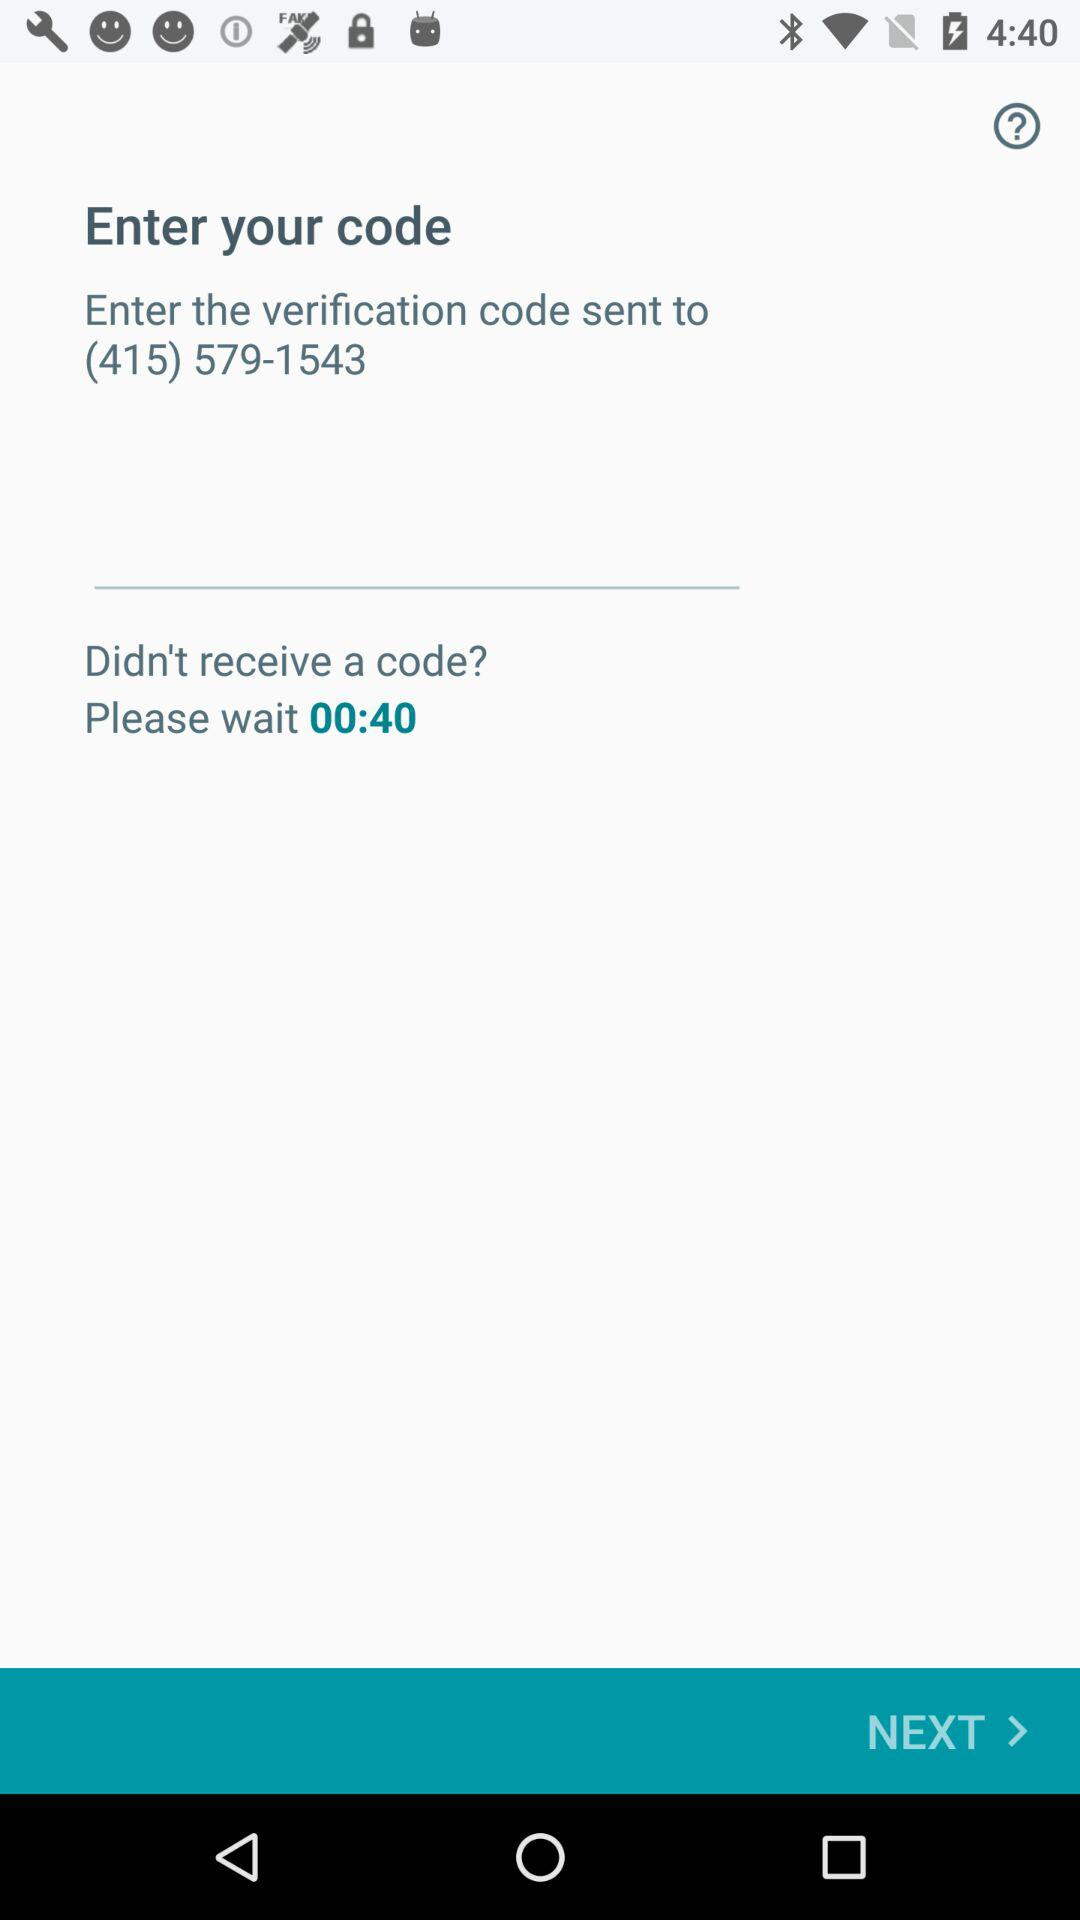How many seconds are left on the countdown timer?
Answer the question using a single word or phrase. 40 